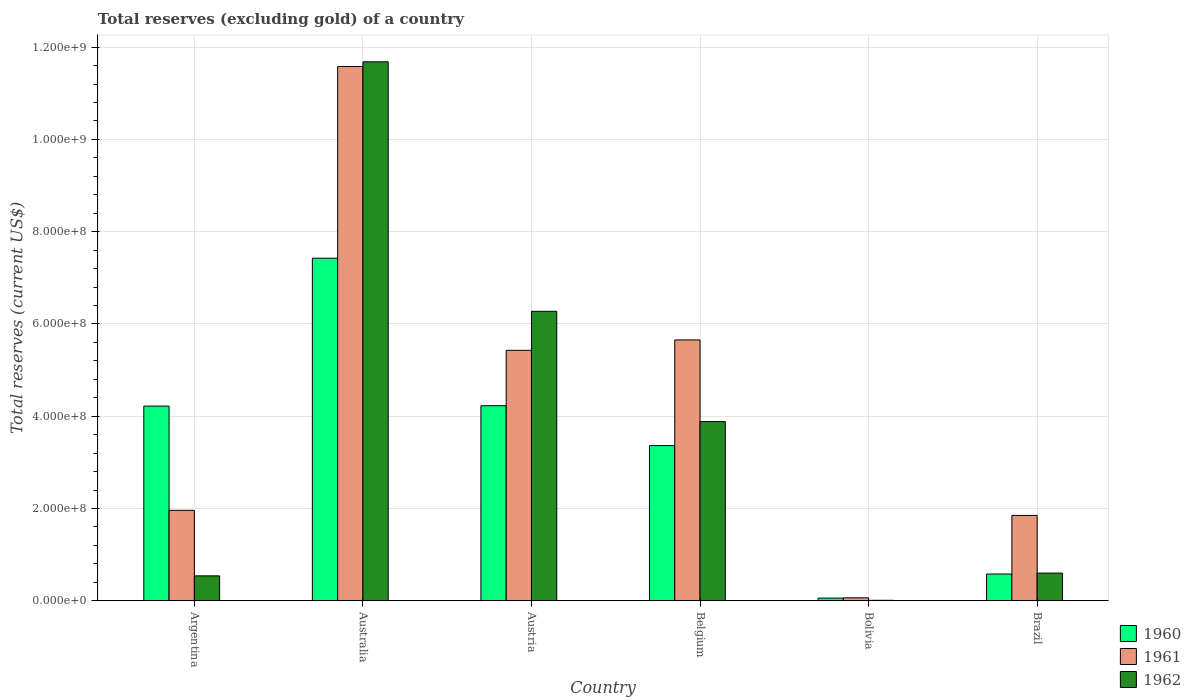Are the number of bars per tick equal to the number of legend labels?
Offer a very short reply. Yes. Are the number of bars on each tick of the X-axis equal?
Give a very brief answer. Yes. How many bars are there on the 5th tick from the left?
Your answer should be very brief. 3. How many bars are there on the 3rd tick from the right?
Your response must be concise. 3. What is the label of the 4th group of bars from the left?
Your answer should be very brief. Belgium. In how many cases, is the number of bars for a given country not equal to the number of legend labels?
Make the answer very short. 0. What is the total reserves (excluding gold) in 1961 in Brazil?
Your answer should be very brief. 1.85e+08. Across all countries, what is the maximum total reserves (excluding gold) in 1962?
Make the answer very short. 1.17e+09. Across all countries, what is the minimum total reserves (excluding gold) in 1961?
Give a very brief answer. 6.40e+06. In which country was the total reserves (excluding gold) in 1962 minimum?
Give a very brief answer. Bolivia. What is the total total reserves (excluding gold) in 1961 in the graph?
Ensure brevity in your answer.  2.65e+09. What is the difference between the total reserves (excluding gold) in 1960 in Belgium and that in Brazil?
Your answer should be compact. 2.78e+08. What is the difference between the total reserves (excluding gold) in 1960 in Austria and the total reserves (excluding gold) in 1962 in Brazil?
Keep it short and to the point. 3.63e+08. What is the average total reserves (excluding gold) in 1960 per country?
Ensure brevity in your answer.  3.31e+08. What is the difference between the total reserves (excluding gold) of/in 1962 and total reserves (excluding gold) of/in 1961 in Austria?
Provide a succinct answer. 8.45e+07. In how many countries, is the total reserves (excluding gold) in 1961 greater than 800000000 US$?
Provide a succinct answer. 1. What is the ratio of the total reserves (excluding gold) in 1961 in Bolivia to that in Brazil?
Make the answer very short. 0.03. Is the total reserves (excluding gold) in 1962 in Australia less than that in Bolivia?
Offer a very short reply. No. Is the difference between the total reserves (excluding gold) in 1962 in Austria and Belgium greater than the difference between the total reserves (excluding gold) in 1961 in Austria and Belgium?
Offer a terse response. Yes. What is the difference between the highest and the second highest total reserves (excluding gold) in 1960?
Provide a short and direct response. -7.60e+05. What is the difference between the highest and the lowest total reserves (excluding gold) in 1961?
Your answer should be compact. 1.15e+09. In how many countries, is the total reserves (excluding gold) in 1961 greater than the average total reserves (excluding gold) in 1961 taken over all countries?
Your response must be concise. 3. Is the sum of the total reserves (excluding gold) in 1962 in Australia and Austria greater than the maximum total reserves (excluding gold) in 1961 across all countries?
Make the answer very short. Yes. What does the 3rd bar from the left in Bolivia represents?
Provide a succinct answer. 1962. Is it the case that in every country, the sum of the total reserves (excluding gold) in 1962 and total reserves (excluding gold) in 1961 is greater than the total reserves (excluding gold) in 1960?
Your answer should be very brief. No. What is the difference between two consecutive major ticks on the Y-axis?
Provide a short and direct response. 2.00e+08. Where does the legend appear in the graph?
Your response must be concise. Bottom right. How many legend labels are there?
Keep it short and to the point. 3. How are the legend labels stacked?
Offer a very short reply. Vertical. What is the title of the graph?
Keep it short and to the point. Total reserves (excluding gold) of a country. What is the label or title of the Y-axis?
Your answer should be very brief. Total reserves (current US$). What is the Total reserves (current US$) of 1960 in Argentina?
Your answer should be compact. 4.22e+08. What is the Total reserves (current US$) of 1961 in Argentina?
Your answer should be compact. 1.96e+08. What is the Total reserves (current US$) in 1962 in Argentina?
Your answer should be compact. 5.40e+07. What is the Total reserves (current US$) in 1960 in Australia?
Your response must be concise. 7.43e+08. What is the Total reserves (current US$) in 1961 in Australia?
Your answer should be very brief. 1.16e+09. What is the Total reserves (current US$) in 1962 in Australia?
Make the answer very short. 1.17e+09. What is the Total reserves (current US$) of 1960 in Austria?
Make the answer very short. 4.23e+08. What is the Total reserves (current US$) of 1961 in Austria?
Your answer should be very brief. 5.43e+08. What is the Total reserves (current US$) of 1962 in Austria?
Offer a very short reply. 6.27e+08. What is the Total reserves (current US$) in 1960 in Belgium?
Offer a very short reply. 3.36e+08. What is the Total reserves (current US$) in 1961 in Belgium?
Provide a short and direct response. 5.65e+08. What is the Total reserves (current US$) in 1962 in Belgium?
Your answer should be compact. 3.88e+08. What is the Total reserves (current US$) in 1960 in Bolivia?
Keep it short and to the point. 5.80e+06. What is the Total reserves (current US$) in 1961 in Bolivia?
Provide a succinct answer. 6.40e+06. What is the Total reserves (current US$) in 1960 in Brazil?
Provide a succinct answer. 5.80e+07. What is the Total reserves (current US$) in 1961 in Brazil?
Your answer should be very brief. 1.85e+08. What is the Total reserves (current US$) of 1962 in Brazil?
Keep it short and to the point. 6.00e+07. Across all countries, what is the maximum Total reserves (current US$) in 1960?
Offer a very short reply. 7.43e+08. Across all countries, what is the maximum Total reserves (current US$) of 1961?
Your answer should be compact. 1.16e+09. Across all countries, what is the maximum Total reserves (current US$) of 1962?
Your answer should be very brief. 1.17e+09. Across all countries, what is the minimum Total reserves (current US$) in 1960?
Offer a very short reply. 5.80e+06. Across all countries, what is the minimum Total reserves (current US$) of 1961?
Make the answer very short. 6.40e+06. What is the total Total reserves (current US$) in 1960 in the graph?
Provide a succinct answer. 1.99e+09. What is the total Total reserves (current US$) in 1961 in the graph?
Provide a succinct answer. 2.65e+09. What is the total Total reserves (current US$) of 1962 in the graph?
Provide a succinct answer. 2.30e+09. What is the difference between the Total reserves (current US$) in 1960 in Argentina and that in Australia?
Ensure brevity in your answer.  -3.21e+08. What is the difference between the Total reserves (current US$) in 1961 in Argentina and that in Australia?
Your answer should be very brief. -9.62e+08. What is the difference between the Total reserves (current US$) of 1962 in Argentina and that in Australia?
Give a very brief answer. -1.11e+09. What is the difference between the Total reserves (current US$) of 1960 in Argentina and that in Austria?
Your response must be concise. -7.60e+05. What is the difference between the Total reserves (current US$) in 1961 in Argentina and that in Austria?
Your answer should be very brief. -3.47e+08. What is the difference between the Total reserves (current US$) of 1962 in Argentina and that in Austria?
Offer a terse response. -5.73e+08. What is the difference between the Total reserves (current US$) of 1960 in Argentina and that in Belgium?
Your response must be concise. 8.56e+07. What is the difference between the Total reserves (current US$) of 1961 in Argentina and that in Belgium?
Offer a very short reply. -3.69e+08. What is the difference between the Total reserves (current US$) of 1962 in Argentina and that in Belgium?
Your response must be concise. -3.34e+08. What is the difference between the Total reserves (current US$) in 1960 in Argentina and that in Bolivia?
Ensure brevity in your answer.  4.16e+08. What is the difference between the Total reserves (current US$) in 1961 in Argentina and that in Bolivia?
Ensure brevity in your answer.  1.90e+08. What is the difference between the Total reserves (current US$) of 1962 in Argentina and that in Bolivia?
Your response must be concise. 5.30e+07. What is the difference between the Total reserves (current US$) in 1960 in Argentina and that in Brazil?
Offer a very short reply. 3.64e+08. What is the difference between the Total reserves (current US$) of 1961 in Argentina and that in Brazil?
Offer a terse response. 1.10e+07. What is the difference between the Total reserves (current US$) of 1962 in Argentina and that in Brazil?
Offer a very short reply. -6.00e+06. What is the difference between the Total reserves (current US$) in 1960 in Australia and that in Austria?
Provide a succinct answer. 3.20e+08. What is the difference between the Total reserves (current US$) in 1961 in Australia and that in Austria?
Your answer should be compact. 6.15e+08. What is the difference between the Total reserves (current US$) of 1962 in Australia and that in Austria?
Ensure brevity in your answer.  5.41e+08. What is the difference between the Total reserves (current US$) of 1960 in Australia and that in Belgium?
Your response must be concise. 4.06e+08. What is the difference between the Total reserves (current US$) in 1961 in Australia and that in Belgium?
Give a very brief answer. 5.93e+08. What is the difference between the Total reserves (current US$) of 1962 in Australia and that in Belgium?
Offer a very short reply. 7.80e+08. What is the difference between the Total reserves (current US$) of 1960 in Australia and that in Bolivia?
Give a very brief answer. 7.37e+08. What is the difference between the Total reserves (current US$) in 1961 in Australia and that in Bolivia?
Provide a short and direct response. 1.15e+09. What is the difference between the Total reserves (current US$) of 1962 in Australia and that in Bolivia?
Your answer should be very brief. 1.17e+09. What is the difference between the Total reserves (current US$) of 1960 in Australia and that in Brazil?
Keep it short and to the point. 6.85e+08. What is the difference between the Total reserves (current US$) in 1961 in Australia and that in Brazil?
Keep it short and to the point. 9.73e+08. What is the difference between the Total reserves (current US$) of 1962 in Australia and that in Brazil?
Your answer should be very brief. 1.11e+09. What is the difference between the Total reserves (current US$) of 1960 in Austria and that in Belgium?
Give a very brief answer. 8.64e+07. What is the difference between the Total reserves (current US$) in 1961 in Austria and that in Belgium?
Your response must be concise. -2.25e+07. What is the difference between the Total reserves (current US$) in 1962 in Austria and that in Belgium?
Give a very brief answer. 2.39e+08. What is the difference between the Total reserves (current US$) of 1960 in Austria and that in Bolivia?
Offer a very short reply. 4.17e+08. What is the difference between the Total reserves (current US$) in 1961 in Austria and that in Bolivia?
Make the answer very short. 5.36e+08. What is the difference between the Total reserves (current US$) of 1962 in Austria and that in Bolivia?
Give a very brief answer. 6.26e+08. What is the difference between the Total reserves (current US$) of 1960 in Austria and that in Brazil?
Ensure brevity in your answer.  3.65e+08. What is the difference between the Total reserves (current US$) in 1961 in Austria and that in Brazil?
Give a very brief answer. 3.58e+08. What is the difference between the Total reserves (current US$) in 1962 in Austria and that in Brazil?
Ensure brevity in your answer.  5.67e+08. What is the difference between the Total reserves (current US$) in 1960 in Belgium and that in Bolivia?
Your answer should be very brief. 3.31e+08. What is the difference between the Total reserves (current US$) in 1961 in Belgium and that in Bolivia?
Give a very brief answer. 5.59e+08. What is the difference between the Total reserves (current US$) in 1962 in Belgium and that in Bolivia?
Provide a succinct answer. 3.87e+08. What is the difference between the Total reserves (current US$) of 1960 in Belgium and that in Brazil?
Provide a succinct answer. 2.78e+08. What is the difference between the Total reserves (current US$) in 1961 in Belgium and that in Brazil?
Ensure brevity in your answer.  3.80e+08. What is the difference between the Total reserves (current US$) of 1962 in Belgium and that in Brazil?
Your response must be concise. 3.28e+08. What is the difference between the Total reserves (current US$) in 1960 in Bolivia and that in Brazil?
Offer a terse response. -5.22e+07. What is the difference between the Total reserves (current US$) in 1961 in Bolivia and that in Brazil?
Keep it short and to the point. -1.79e+08. What is the difference between the Total reserves (current US$) of 1962 in Bolivia and that in Brazil?
Offer a terse response. -5.90e+07. What is the difference between the Total reserves (current US$) of 1960 in Argentina and the Total reserves (current US$) of 1961 in Australia?
Keep it short and to the point. -7.36e+08. What is the difference between the Total reserves (current US$) in 1960 in Argentina and the Total reserves (current US$) in 1962 in Australia?
Your answer should be very brief. -7.46e+08. What is the difference between the Total reserves (current US$) of 1961 in Argentina and the Total reserves (current US$) of 1962 in Australia?
Give a very brief answer. -9.72e+08. What is the difference between the Total reserves (current US$) of 1960 in Argentina and the Total reserves (current US$) of 1961 in Austria?
Your response must be concise. -1.21e+08. What is the difference between the Total reserves (current US$) of 1960 in Argentina and the Total reserves (current US$) of 1962 in Austria?
Make the answer very short. -2.05e+08. What is the difference between the Total reserves (current US$) in 1961 in Argentina and the Total reserves (current US$) in 1962 in Austria?
Ensure brevity in your answer.  -4.31e+08. What is the difference between the Total reserves (current US$) of 1960 in Argentina and the Total reserves (current US$) of 1961 in Belgium?
Your answer should be compact. -1.43e+08. What is the difference between the Total reserves (current US$) of 1960 in Argentina and the Total reserves (current US$) of 1962 in Belgium?
Offer a terse response. 3.36e+07. What is the difference between the Total reserves (current US$) of 1961 in Argentina and the Total reserves (current US$) of 1962 in Belgium?
Your answer should be compact. -1.92e+08. What is the difference between the Total reserves (current US$) of 1960 in Argentina and the Total reserves (current US$) of 1961 in Bolivia?
Your answer should be very brief. 4.16e+08. What is the difference between the Total reserves (current US$) of 1960 in Argentina and the Total reserves (current US$) of 1962 in Bolivia?
Keep it short and to the point. 4.21e+08. What is the difference between the Total reserves (current US$) of 1961 in Argentina and the Total reserves (current US$) of 1962 in Bolivia?
Offer a terse response. 1.95e+08. What is the difference between the Total reserves (current US$) of 1960 in Argentina and the Total reserves (current US$) of 1961 in Brazil?
Keep it short and to the point. 2.37e+08. What is the difference between the Total reserves (current US$) in 1960 in Argentina and the Total reserves (current US$) in 1962 in Brazil?
Give a very brief answer. 3.62e+08. What is the difference between the Total reserves (current US$) of 1961 in Argentina and the Total reserves (current US$) of 1962 in Brazil?
Your answer should be compact. 1.36e+08. What is the difference between the Total reserves (current US$) of 1960 in Australia and the Total reserves (current US$) of 1961 in Austria?
Offer a very short reply. 2.00e+08. What is the difference between the Total reserves (current US$) of 1960 in Australia and the Total reserves (current US$) of 1962 in Austria?
Ensure brevity in your answer.  1.15e+08. What is the difference between the Total reserves (current US$) in 1961 in Australia and the Total reserves (current US$) in 1962 in Austria?
Your answer should be compact. 5.31e+08. What is the difference between the Total reserves (current US$) in 1960 in Australia and the Total reserves (current US$) in 1961 in Belgium?
Your answer should be compact. 1.77e+08. What is the difference between the Total reserves (current US$) in 1960 in Australia and the Total reserves (current US$) in 1962 in Belgium?
Ensure brevity in your answer.  3.54e+08. What is the difference between the Total reserves (current US$) in 1961 in Australia and the Total reserves (current US$) in 1962 in Belgium?
Make the answer very short. 7.70e+08. What is the difference between the Total reserves (current US$) of 1960 in Australia and the Total reserves (current US$) of 1961 in Bolivia?
Your answer should be compact. 7.36e+08. What is the difference between the Total reserves (current US$) in 1960 in Australia and the Total reserves (current US$) in 1962 in Bolivia?
Your answer should be compact. 7.42e+08. What is the difference between the Total reserves (current US$) of 1961 in Australia and the Total reserves (current US$) of 1962 in Bolivia?
Your response must be concise. 1.16e+09. What is the difference between the Total reserves (current US$) in 1960 in Australia and the Total reserves (current US$) in 1961 in Brazil?
Make the answer very short. 5.58e+08. What is the difference between the Total reserves (current US$) in 1960 in Australia and the Total reserves (current US$) in 1962 in Brazil?
Provide a short and direct response. 6.83e+08. What is the difference between the Total reserves (current US$) in 1961 in Australia and the Total reserves (current US$) in 1962 in Brazil?
Give a very brief answer. 1.10e+09. What is the difference between the Total reserves (current US$) in 1960 in Austria and the Total reserves (current US$) in 1961 in Belgium?
Provide a short and direct response. -1.43e+08. What is the difference between the Total reserves (current US$) of 1960 in Austria and the Total reserves (current US$) of 1962 in Belgium?
Provide a short and direct response. 3.44e+07. What is the difference between the Total reserves (current US$) of 1961 in Austria and the Total reserves (current US$) of 1962 in Belgium?
Keep it short and to the point. 1.54e+08. What is the difference between the Total reserves (current US$) in 1960 in Austria and the Total reserves (current US$) in 1961 in Bolivia?
Keep it short and to the point. 4.16e+08. What is the difference between the Total reserves (current US$) in 1960 in Austria and the Total reserves (current US$) in 1962 in Bolivia?
Ensure brevity in your answer.  4.22e+08. What is the difference between the Total reserves (current US$) in 1961 in Austria and the Total reserves (current US$) in 1962 in Bolivia?
Your response must be concise. 5.42e+08. What is the difference between the Total reserves (current US$) of 1960 in Austria and the Total reserves (current US$) of 1961 in Brazil?
Provide a succinct answer. 2.38e+08. What is the difference between the Total reserves (current US$) of 1960 in Austria and the Total reserves (current US$) of 1962 in Brazil?
Provide a succinct answer. 3.63e+08. What is the difference between the Total reserves (current US$) of 1961 in Austria and the Total reserves (current US$) of 1962 in Brazil?
Make the answer very short. 4.83e+08. What is the difference between the Total reserves (current US$) of 1960 in Belgium and the Total reserves (current US$) of 1961 in Bolivia?
Your answer should be compact. 3.30e+08. What is the difference between the Total reserves (current US$) of 1960 in Belgium and the Total reserves (current US$) of 1962 in Bolivia?
Make the answer very short. 3.35e+08. What is the difference between the Total reserves (current US$) of 1961 in Belgium and the Total reserves (current US$) of 1962 in Bolivia?
Your answer should be compact. 5.64e+08. What is the difference between the Total reserves (current US$) in 1960 in Belgium and the Total reserves (current US$) in 1961 in Brazil?
Keep it short and to the point. 1.51e+08. What is the difference between the Total reserves (current US$) in 1960 in Belgium and the Total reserves (current US$) in 1962 in Brazil?
Offer a very short reply. 2.76e+08. What is the difference between the Total reserves (current US$) in 1961 in Belgium and the Total reserves (current US$) in 1962 in Brazil?
Your response must be concise. 5.05e+08. What is the difference between the Total reserves (current US$) of 1960 in Bolivia and the Total reserves (current US$) of 1961 in Brazil?
Your answer should be compact. -1.79e+08. What is the difference between the Total reserves (current US$) of 1960 in Bolivia and the Total reserves (current US$) of 1962 in Brazil?
Your response must be concise. -5.42e+07. What is the difference between the Total reserves (current US$) in 1961 in Bolivia and the Total reserves (current US$) in 1962 in Brazil?
Your response must be concise. -5.36e+07. What is the average Total reserves (current US$) of 1960 per country?
Offer a very short reply. 3.31e+08. What is the average Total reserves (current US$) in 1961 per country?
Make the answer very short. 4.42e+08. What is the average Total reserves (current US$) in 1962 per country?
Offer a terse response. 3.83e+08. What is the difference between the Total reserves (current US$) in 1960 and Total reserves (current US$) in 1961 in Argentina?
Your answer should be compact. 2.26e+08. What is the difference between the Total reserves (current US$) of 1960 and Total reserves (current US$) of 1962 in Argentina?
Keep it short and to the point. 3.68e+08. What is the difference between the Total reserves (current US$) of 1961 and Total reserves (current US$) of 1962 in Argentina?
Your response must be concise. 1.42e+08. What is the difference between the Total reserves (current US$) of 1960 and Total reserves (current US$) of 1961 in Australia?
Offer a terse response. -4.15e+08. What is the difference between the Total reserves (current US$) in 1960 and Total reserves (current US$) in 1962 in Australia?
Offer a very short reply. -4.26e+08. What is the difference between the Total reserves (current US$) of 1961 and Total reserves (current US$) of 1962 in Australia?
Your response must be concise. -1.02e+07. What is the difference between the Total reserves (current US$) in 1960 and Total reserves (current US$) in 1961 in Austria?
Provide a succinct answer. -1.20e+08. What is the difference between the Total reserves (current US$) of 1960 and Total reserves (current US$) of 1962 in Austria?
Your response must be concise. -2.05e+08. What is the difference between the Total reserves (current US$) of 1961 and Total reserves (current US$) of 1962 in Austria?
Your answer should be very brief. -8.45e+07. What is the difference between the Total reserves (current US$) in 1960 and Total reserves (current US$) in 1961 in Belgium?
Offer a very short reply. -2.29e+08. What is the difference between the Total reserves (current US$) in 1960 and Total reserves (current US$) in 1962 in Belgium?
Provide a succinct answer. -5.20e+07. What is the difference between the Total reserves (current US$) of 1961 and Total reserves (current US$) of 1962 in Belgium?
Your answer should be compact. 1.77e+08. What is the difference between the Total reserves (current US$) of 1960 and Total reserves (current US$) of 1961 in Bolivia?
Keep it short and to the point. -6.00e+05. What is the difference between the Total reserves (current US$) in 1960 and Total reserves (current US$) in 1962 in Bolivia?
Provide a succinct answer. 4.80e+06. What is the difference between the Total reserves (current US$) of 1961 and Total reserves (current US$) of 1962 in Bolivia?
Ensure brevity in your answer.  5.40e+06. What is the difference between the Total reserves (current US$) of 1960 and Total reserves (current US$) of 1961 in Brazil?
Provide a short and direct response. -1.27e+08. What is the difference between the Total reserves (current US$) in 1960 and Total reserves (current US$) in 1962 in Brazil?
Offer a very short reply. -2.00e+06. What is the difference between the Total reserves (current US$) in 1961 and Total reserves (current US$) in 1962 in Brazil?
Ensure brevity in your answer.  1.25e+08. What is the ratio of the Total reserves (current US$) of 1960 in Argentina to that in Australia?
Provide a short and direct response. 0.57. What is the ratio of the Total reserves (current US$) of 1961 in Argentina to that in Australia?
Your response must be concise. 0.17. What is the ratio of the Total reserves (current US$) of 1962 in Argentina to that in Australia?
Offer a terse response. 0.05. What is the ratio of the Total reserves (current US$) of 1961 in Argentina to that in Austria?
Offer a terse response. 0.36. What is the ratio of the Total reserves (current US$) in 1962 in Argentina to that in Austria?
Make the answer very short. 0.09. What is the ratio of the Total reserves (current US$) of 1960 in Argentina to that in Belgium?
Ensure brevity in your answer.  1.25. What is the ratio of the Total reserves (current US$) in 1961 in Argentina to that in Belgium?
Your response must be concise. 0.35. What is the ratio of the Total reserves (current US$) of 1962 in Argentina to that in Belgium?
Offer a very short reply. 0.14. What is the ratio of the Total reserves (current US$) of 1960 in Argentina to that in Bolivia?
Make the answer very short. 72.76. What is the ratio of the Total reserves (current US$) in 1961 in Argentina to that in Bolivia?
Your response must be concise. 30.62. What is the ratio of the Total reserves (current US$) of 1962 in Argentina to that in Bolivia?
Provide a succinct answer. 54. What is the ratio of the Total reserves (current US$) in 1960 in Argentina to that in Brazil?
Keep it short and to the point. 7.28. What is the ratio of the Total reserves (current US$) in 1961 in Argentina to that in Brazil?
Offer a very short reply. 1.06. What is the ratio of the Total reserves (current US$) in 1960 in Australia to that in Austria?
Your answer should be very brief. 1.76. What is the ratio of the Total reserves (current US$) of 1961 in Australia to that in Austria?
Keep it short and to the point. 2.13. What is the ratio of the Total reserves (current US$) of 1962 in Australia to that in Austria?
Ensure brevity in your answer.  1.86. What is the ratio of the Total reserves (current US$) in 1960 in Australia to that in Belgium?
Ensure brevity in your answer.  2.21. What is the ratio of the Total reserves (current US$) in 1961 in Australia to that in Belgium?
Make the answer very short. 2.05. What is the ratio of the Total reserves (current US$) in 1962 in Australia to that in Belgium?
Your answer should be very brief. 3.01. What is the ratio of the Total reserves (current US$) of 1960 in Australia to that in Bolivia?
Your response must be concise. 128.03. What is the ratio of the Total reserves (current US$) in 1961 in Australia to that in Bolivia?
Offer a terse response. 180.94. What is the ratio of the Total reserves (current US$) of 1962 in Australia to that in Bolivia?
Your answer should be compact. 1168.18. What is the ratio of the Total reserves (current US$) of 1960 in Australia to that in Brazil?
Your answer should be very brief. 12.8. What is the ratio of the Total reserves (current US$) in 1961 in Australia to that in Brazil?
Make the answer very short. 6.26. What is the ratio of the Total reserves (current US$) in 1962 in Australia to that in Brazil?
Your answer should be very brief. 19.47. What is the ratio of the Total reserves (current US$) in 1960 in Austria to that in Belgium?
Give a very brief answer. 1.26. What is the ratio of the Total reserves (current US$) in 1961 in Austria to that in Belgium?
Your response must be concise. 0.96. What is the ratio of the Total reserves (current US$) of 1962 in Austria to that in Belgium?
Your answer should be very brief. 1.62. What is the ratio of the Total reserves (current US$) of 1960 in Austria to that in Bolivia?
Your answer should be very brief. 72.89. What is the ratio of the Total reserves (current US$) in 1961 in Austria to that in Bolivia?
Ensure brevity in your answer.  84.82. What is the ratio of the Total reserves (current US$) in 1962 in Austria to that in Bolivia?
Keep it short and to the point. 627.38. What is the ratio of the Total reserves (current US$) in 1960 in Austria to that in Brazil?
Make the answer very short. 7.29. What is the ratio of the Total reserves (current US$) of 1961 in Austria to that in Brazil?
Your answer should be very brief. 2.93. What is the ratio of the Total reserves (current US$) in 1962 in Austria to that in Brazil?
Make the answer very short. 10.46. What is the ratio of the Total reserves (current US$) in 1960 in Belgium to that in Bolivia?
Provide a short and direct response. 58. What is the ratio of the Total reserves (current US$) in 1961 in Belgium to that in Bolivia?
Your response must be concise. 88.34. What is the ratio of the Total reserves (current US$) in 1962 in Belgium to that in Bolivia?
Offer a terse response. 388.39. What is the ratio of the Total reserves (current US$) in 1960 in Belgium to that in Brazil?
Offer a terse response. 5.8. What is the ratio of the Total reserves (current US$) of 1961 in Belgium to that in Brazil?
Your answer should be compact. 3.06. What is the ratio of the Total reserves (current US$) in 1962 in Belgium to that in Brazil?
Make the answer very short. 6.47. What is the ratio of the Total reserves (current US$) in 1961 in Bolivia to that in Brazil?
Ensure brevity in your answer.  0.03. What is the ratio of the Total reserves (current US$) in 1962 in Bolivia to that in Brazil?
Make the answer very short. 0.02. What is the difference between the highest and the second highest Total reserves (current US$) in 1960?
Keep it short and to the point. 3.20e+08. What is the difference between the highest and the second highest Total reserves (current US$) of 1961?
Your response must be concise. 5.93e+08. What is the difference between the highest and the second highest Total reserves (current US$) of 1962?
Keep it short and to the point. 5.41e+08. What is the difference between the highest and the lowest Total reserves (current US$) of 1960?
Provide a succinct answer. 7.37e+08. What is the difference between the highest and the lowest Total reserves (current US$) in 1961?
Make the answer very short. 1.15e+09. What is the difference between the highest and the lowest Total reserves (current US$) in 1962?
Ensure brevity in your answer.  1.17e+09. 